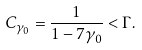<formula> <loc_0><loc_0><loc_500><loc_500>C _ { \gamma _ { 0 } } = \frac { 1 } { 1 - 7 \gamma _ { 0 } } < \Gamma .</formula> 